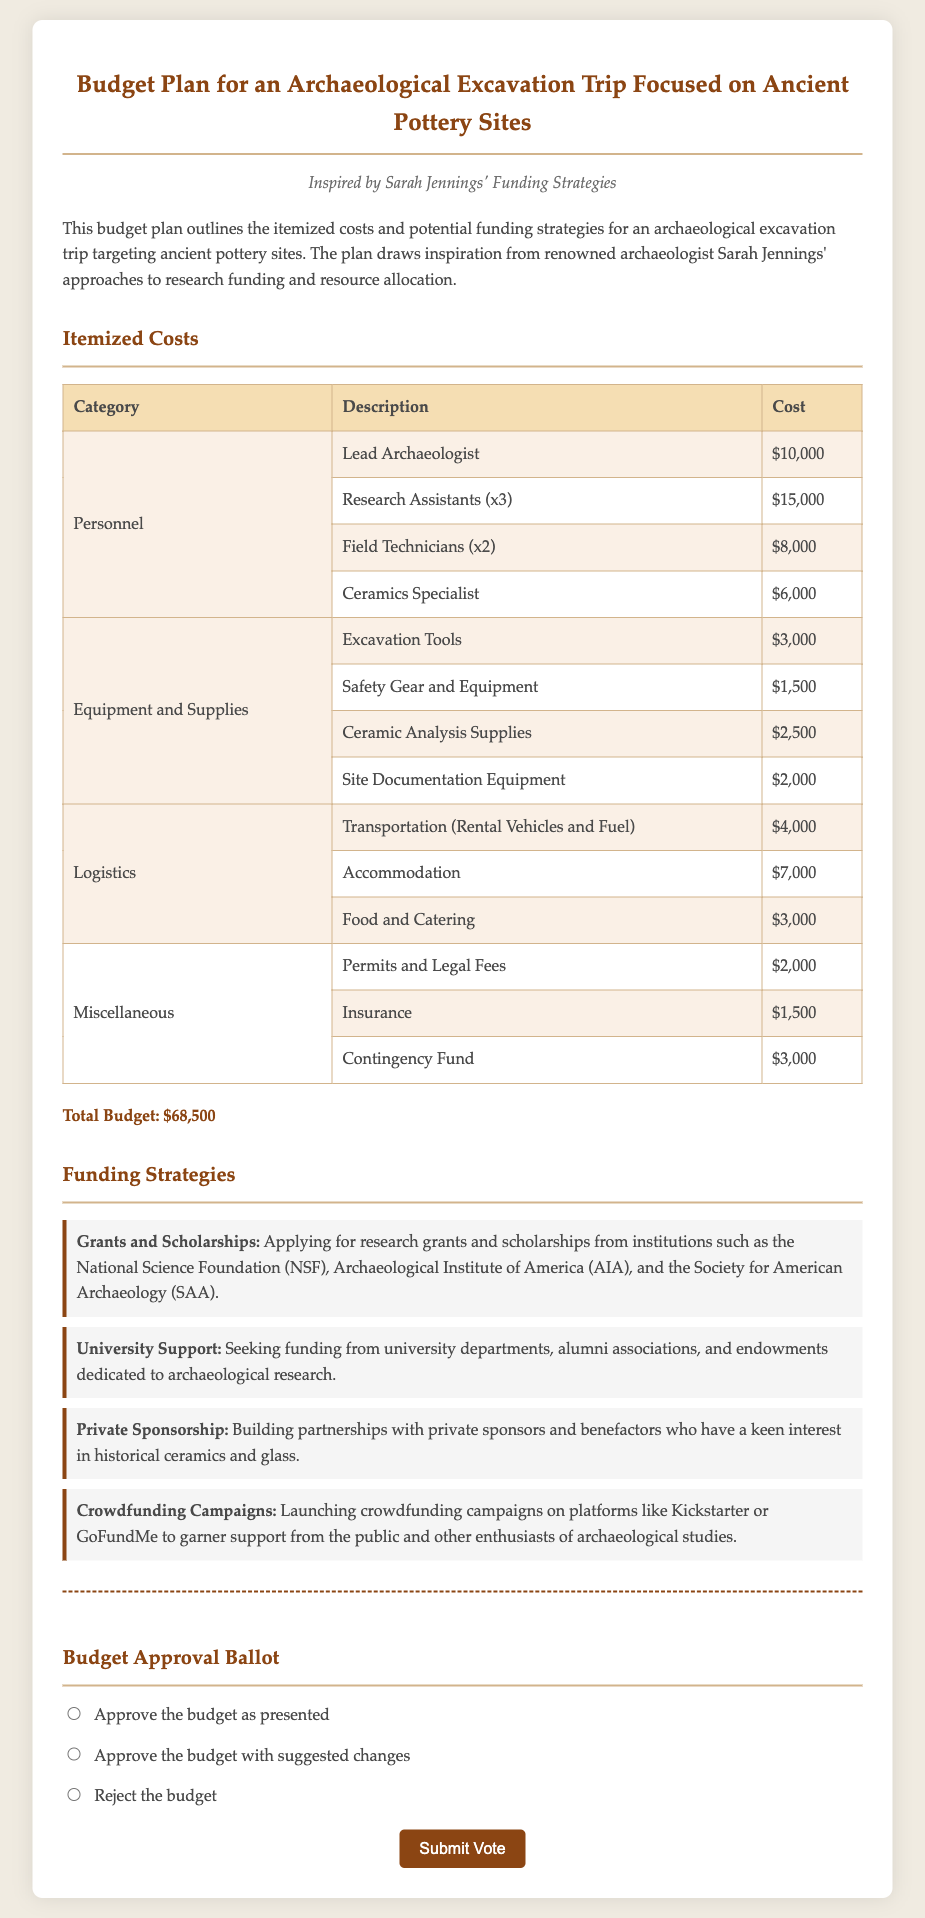What is the total budget? The total budget is calculated by summing all itemized costs as presented in the document.
Answer: $68,500 How many research assistants are included in the budget? The document specifies that there are three research assistants included in the personnel costs.
Answer: 3 What is the cost for excavation tools? The document lists excavation tools under equipment and supplies with a specific cost.
Answer: $3,000 Which organization is mentioned for applying grants? The document mentions the National Science Foundation (NSF) as one of the organizations for grants.
Answer: National Science Foundation (NSF) What is the primary focus of the excavation trip? The document clearly states that the excavation trip is focused on ancient pottery sites.
Answer: ancient pottery sites What is one of the funding strategies mentioned? The document outlines several strategies, including crowdfunding campaigns as a means of funding.
Answer: Crowdfunding Campaigns What does the budget approval ballot allow the participants to do? The document contains a section for participants to indicate their vote regarding the budget approval.
Answer: indicate their vote How many categories are there in the itemized costs section? The itemized costs section is divided into multiple categories which can be counted for clarity.
Answer: 4 What is the cost for permits and legal fees? The document specifies this cost under the miscellaneous category.
Answer: $2,000 